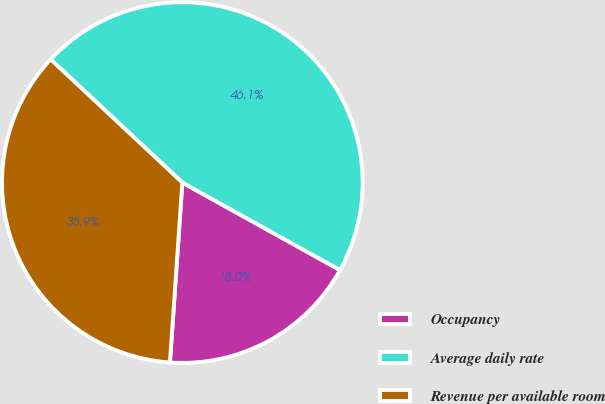Convert chart. <chart><loc_0><loc_0><loc_500><loc_500><pie_chart><fcel>Occupancy<fcel>Average daily rate<fcel>Revenue per available room<nl><fcel>18.03%<fcel>46.09%<fcel>35.87%<nl></chart> 